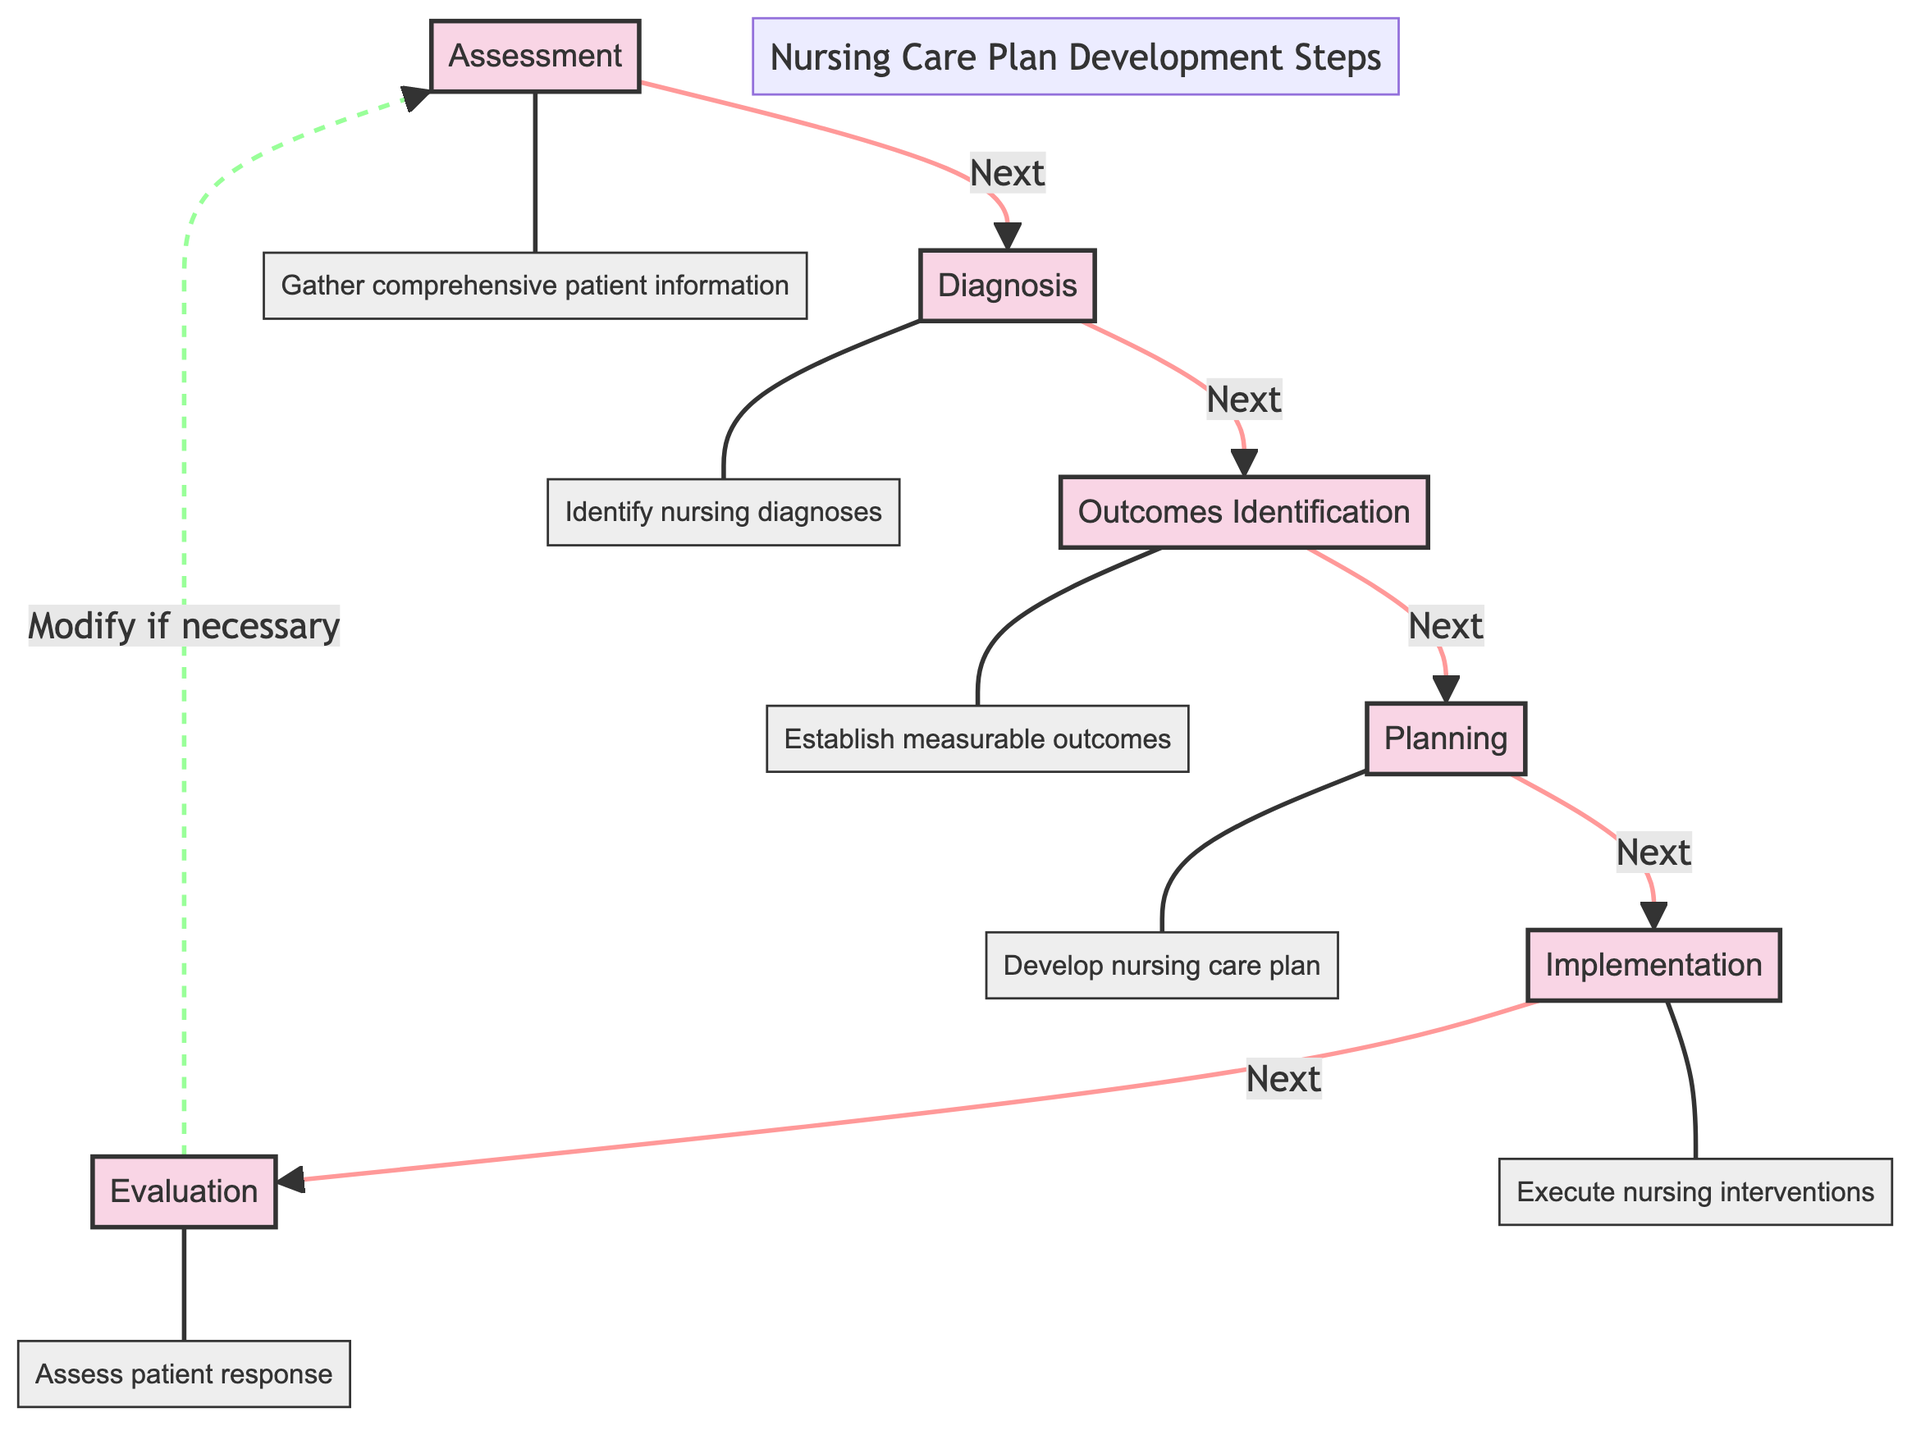What is the first step in the nursing care plan development? The flow chart starts with the node labeled "Assessment," which indicates that this is the initial step in the process.
Answer: Assessment What is the last step in the nursing care plan development? According to the flow chart, the last step is labeled "Evaluation," which is where the process ends.
Answer: Evaluation How many steps are there in the nursing care plan development? Counting the distinct steps listed in the flow chart, there are a total of six steps from Assessment to Evaluation.
Answer: 6 What step follows "Diagnosis"? The flow chart shows an arrow from "Diagnosis" to "Outcomes Identification," indicating that "Outcomes Identification" is the next step in the sequence.
Answer: Outcomes Identification What action is taken during the "Implementation" step? The description connected to "Implementation" states that the nursing interventions are executed as outlined in the care plan, which is the primary action in this step.
Answer: Execute nursing interventions What does the arrow looping back to "Assessment" indicate? The dashed arrow returning to "Assessment" suggests that after "Evaluation," the process may cycle back to the assessment phase if modifications to the care plan are necessary based on patient response.
Answer: Modify if necessary What is established during the "Outcomes Identification" step? The description for "Outcomes Identification" notes that this step involves establishing measurable and realistic patient outcomes that address nursing diagnoses.
Answer: Measurable outcomes Which step follows "Planning"? Following the sequential flow in the chart, "Implementation" is designated as the step that comes next after "Planning."
Answer: Implementation What is the focus of the "Diagnosis" step? The focus of "Diagnosis," as described, is to identify nursing diagnoses based on the collected assessment data, highlighting health issues.
Answer: Identify nursing diagnoses 